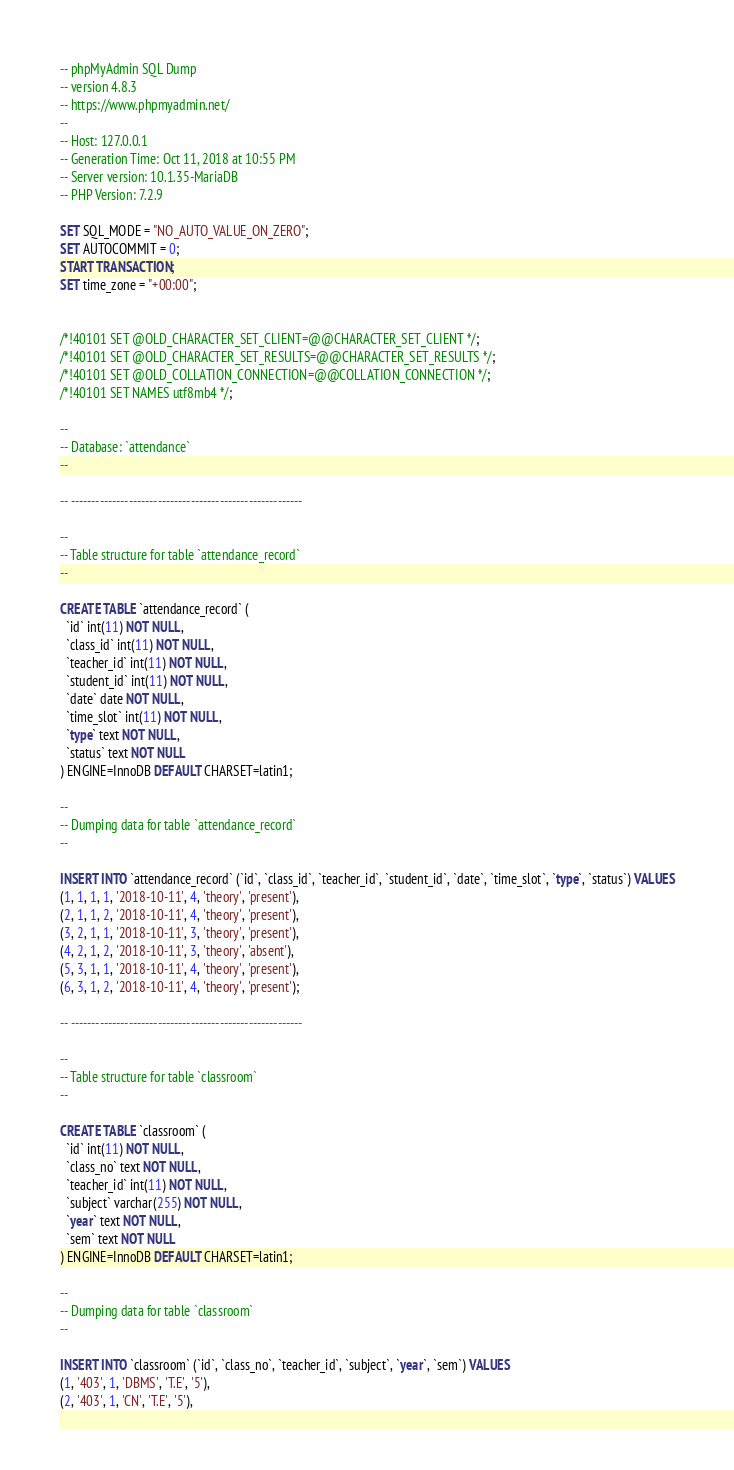Convert code to text. <code><loc_0><loc_0><loc_500><loc_500><_SQL_>-- phpMyAdmin SQL Dump
-- version 4.8.3
-- https://www.phpmyadmin.net/
--
-- Host: 127.0.0.1
-- Generation Time: Oct 11, 2018 at 10:55 PM
-- Server version: 10.1.35-MariaDB
-- PHP Version: 7.2.9

SET SQL_MODE = "NO_AUTO_VALUE_ON_ZERO";
SET AUTOCOMMIT = 0;
START TRANSACTION;
SET time_zone = "+00:00";


/*!40101 SET @OLD_CHARACTER_SET_CLIENT=@@CHARACTER_SET_CLIENT */;
/*!40101 SET @OLD_CHARACTER_SET_RESULTS=@@CHARACTER_SET_RESULTS */;
/*!40101 SET @OLD_COLLATION_CONNECTION=@@COLLATION_CONNECTION */;
/*!40101 SET NAMES utf8mb4 */;

--
-- Database: `attendance`
--

-- --------------------------------------------------------

--
-- Table structure for table `attendance_record`
--

CREATE TABLE `attendance_record` (
  `id` int(11) NOT NULL,
  `class_id` int(11) NOT NULL,
  `teacher_id` int(11) NOT NULL,
  `student_id` int(11) NOT NULL,
  `date` date NOT NULL,
  `time_slot` int(11) NOT NULL,
  `type` text NOT NULL,
  `status` text NOT NULL
) ENGINE=InnoDB DEFAULT CHARSET=latin1;

--
-- Dumping data for table `attendance_record`
--

INSERT INTO `attendance_record` (`id`, `class_id`, `teacher_id`, `student_id`, `date`, `time_slot`, `type`, `status`) VALUES
(1, 1, 1, 1, '2018-10-11', 4, 'theory', 'present'),
(2, 1, 1, 2, '2018-10-11', 4, 'theory', 'present'),
(3, 2, 1, 1, '2018-10-11', 3, 'theory', 'present'),
(4, 2, 1, 2, '2018-10-11', 3, 'theory', 'absent'),
(5, 3, 1, 1, '2018-10-11', 4, 'theory', 'present'),
(6, 3, 1, 2, '2018-10-11', 4, 'theory', 'present');

-- --------------------------------------------------------

--
-- Table structure for table `classroom`
--

CREATE TABLE `classroom` (
  `id` int(11) NOT NULL,
  `class_no` text NOT NULL,
  `teacher_id` int(11) NOT NULL,
  `subject` varchar(255) NOT NULL,
  `year` text NOT NULL,
  `sem` text NOT NULL
) ENGINE=InnoDB DEFAULT CHARSET=latin1;

--
-- Dumping data for table `classroom`
--

INSERT INTO `classroom` (`id`, `class_no`, `teacher_id`, `subject`, `year`, `sem`) VALUES
(1, '403', 1, 'DBMS', 'T.E', '5'),
(2, '403', 1, 'CN', 'T.E', '5'),</code> 